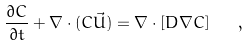Convert formula to latex. <formula><loc_0><loc_0><loc_500><loc_500>\frac { \partial C } { \partial t } + \nabla \cdot ( C \vec { U } ) = \nabla \cdot [ D \nabla C ] \quad ,</formula> 